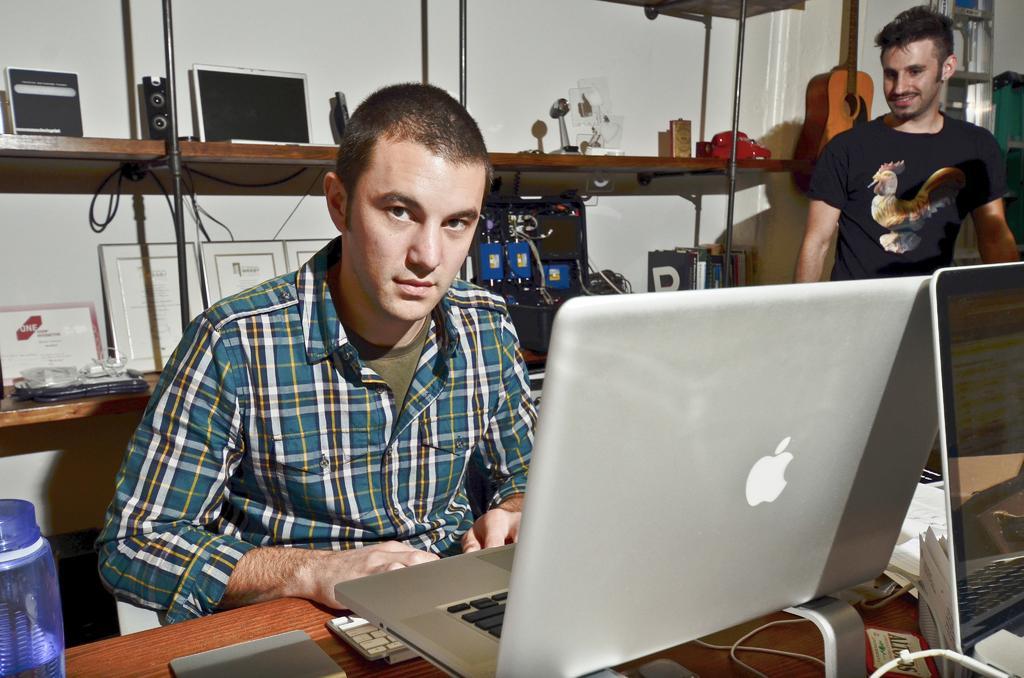In one or two sentences, can you explain what this image depicts? This is the picture where we have two people in the screen the one is sitting on the chair in front of the table where we have a laptop and the one is standing beside him and there is a shelf where some things are placed. 